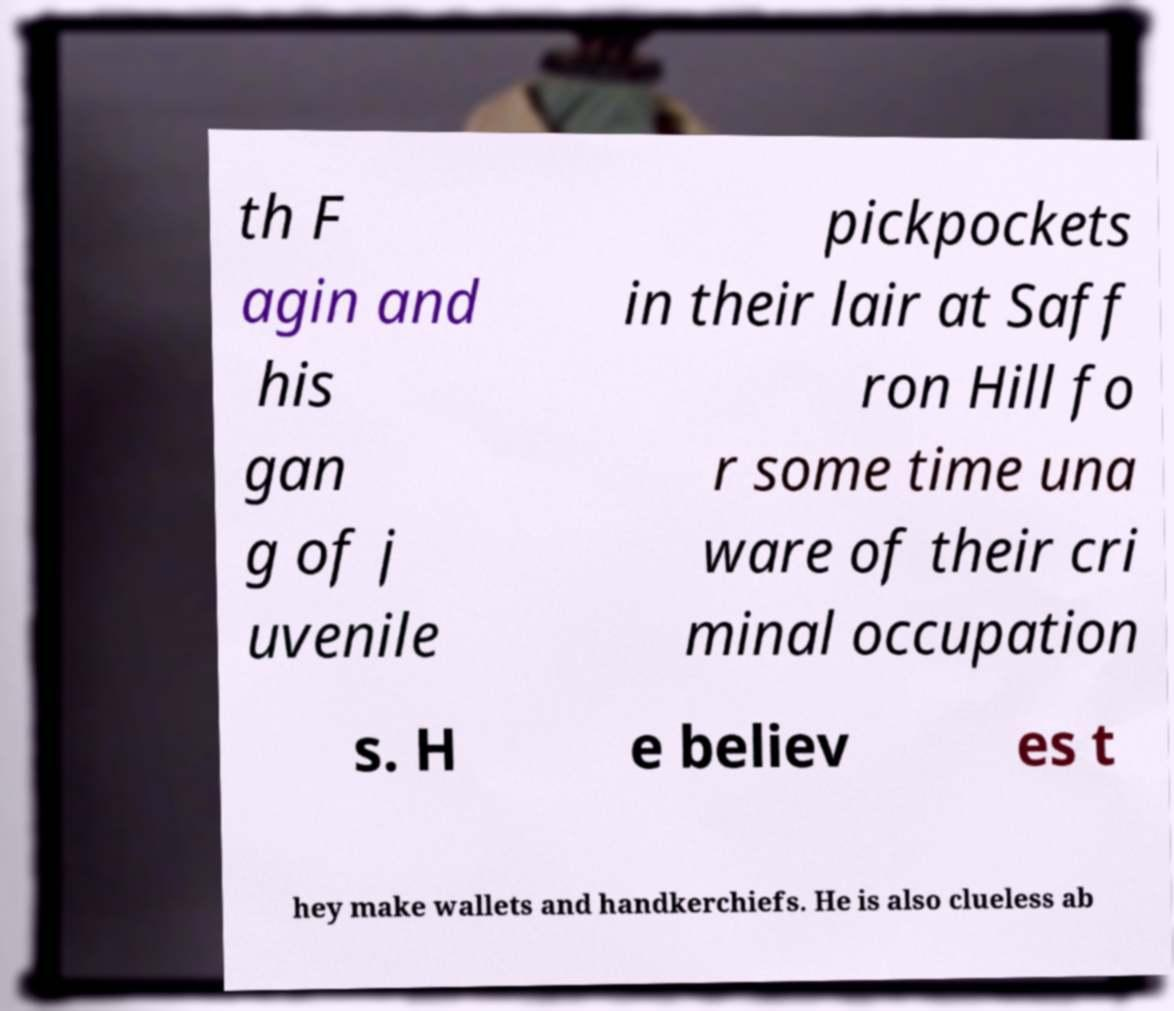For documentation purposes, I need the text within this image transcribed. Could you provide that? th F agin and his gan g of j uvenile pickpockets in their lair at Saff ron Hill fo r some time una ware of their cri minal occupation s. H e believ es t hey make wallets and handkerchiefs. He is also clueless ab 